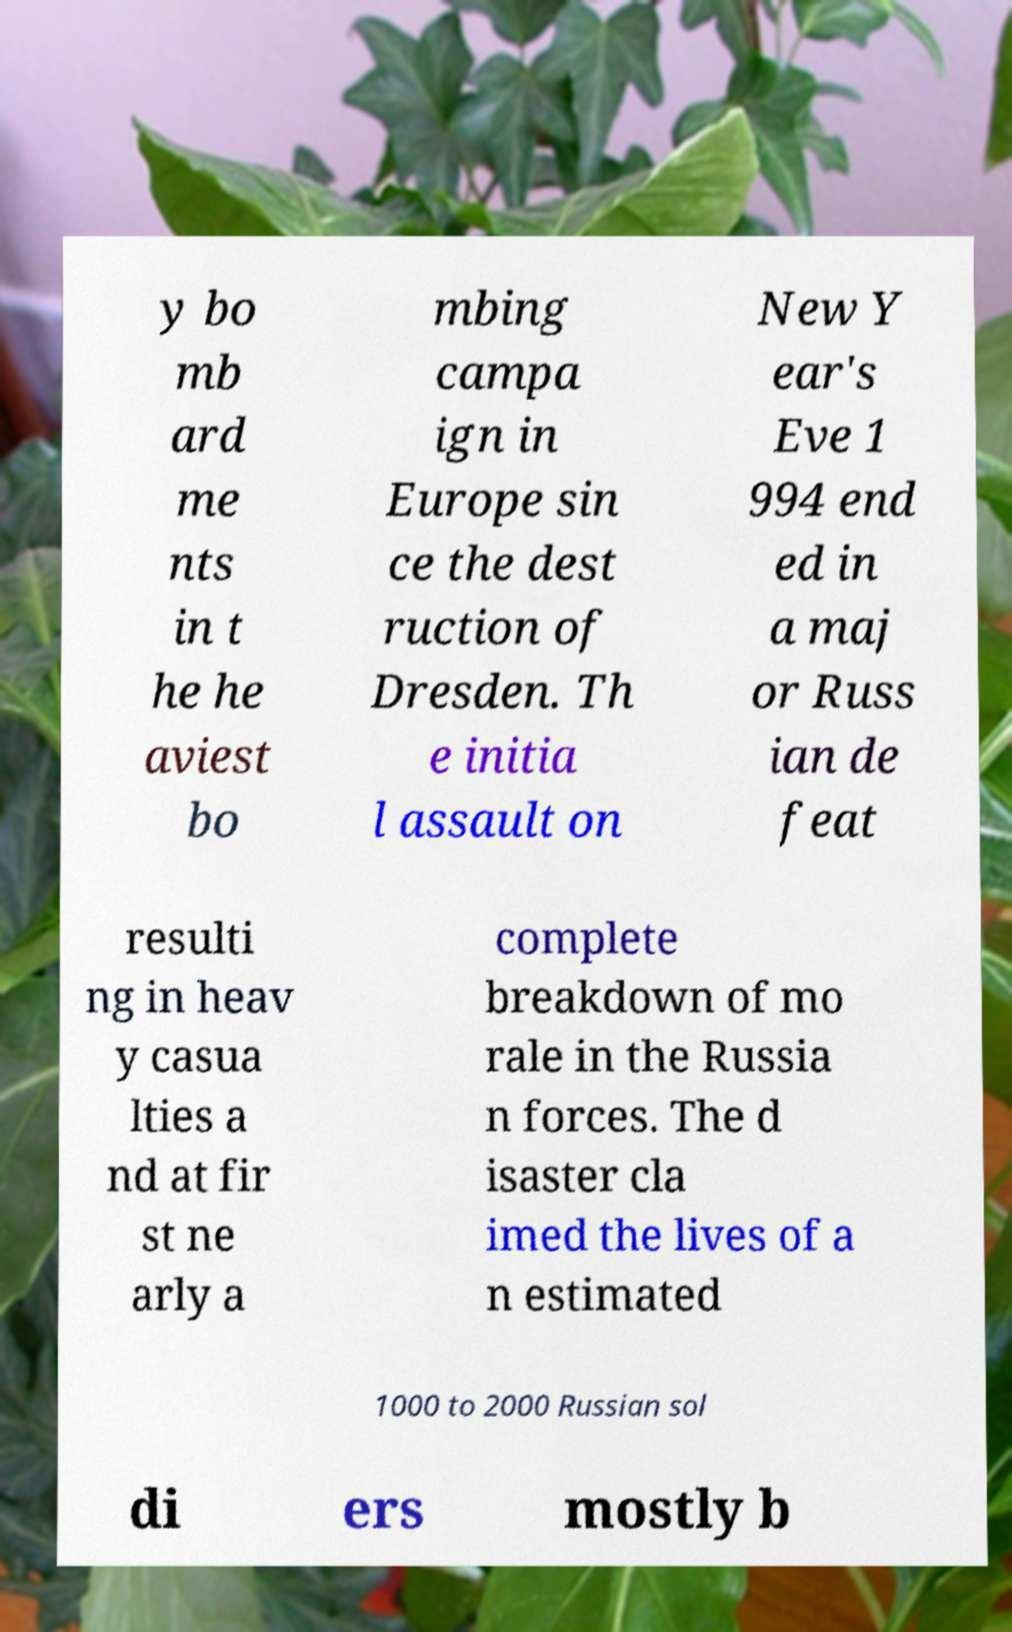What messages or text are displayed in this image? I need them in a readable, typed format. y bo mb ard me nts in t he he aviest bo mbing campa ign in Europe sin ce the dest ruction of Dresden. Th e initia l assault on New Y ear's Eve 1 994 end ed in a maj or Russ ian de feat resulti ng in heav y casua lties a nd at fir st ne arly a complete breakdown of mo rale in the Russia n forces. The d isaster cla imed the lives of a n estimated 1000 to 2000 Russian sol di ers mostly b 